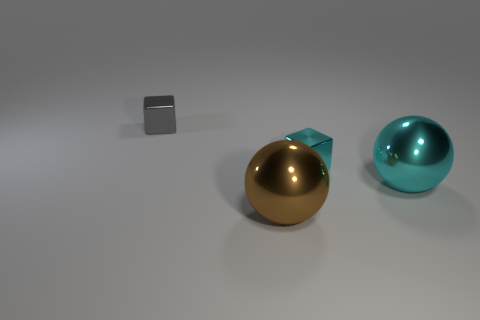Add 3 cyan objects. How many objects exist? 7 Subtract all big cyan metallic things. Subtract all brown balls. How many objects are left? 2 Add 3 blocks. How many blocks are left? 5 Add 3 large cyan spheres. How many large cyan spheres exist? 4 Subtract 0 blue spheres. How many objects are left? 4 